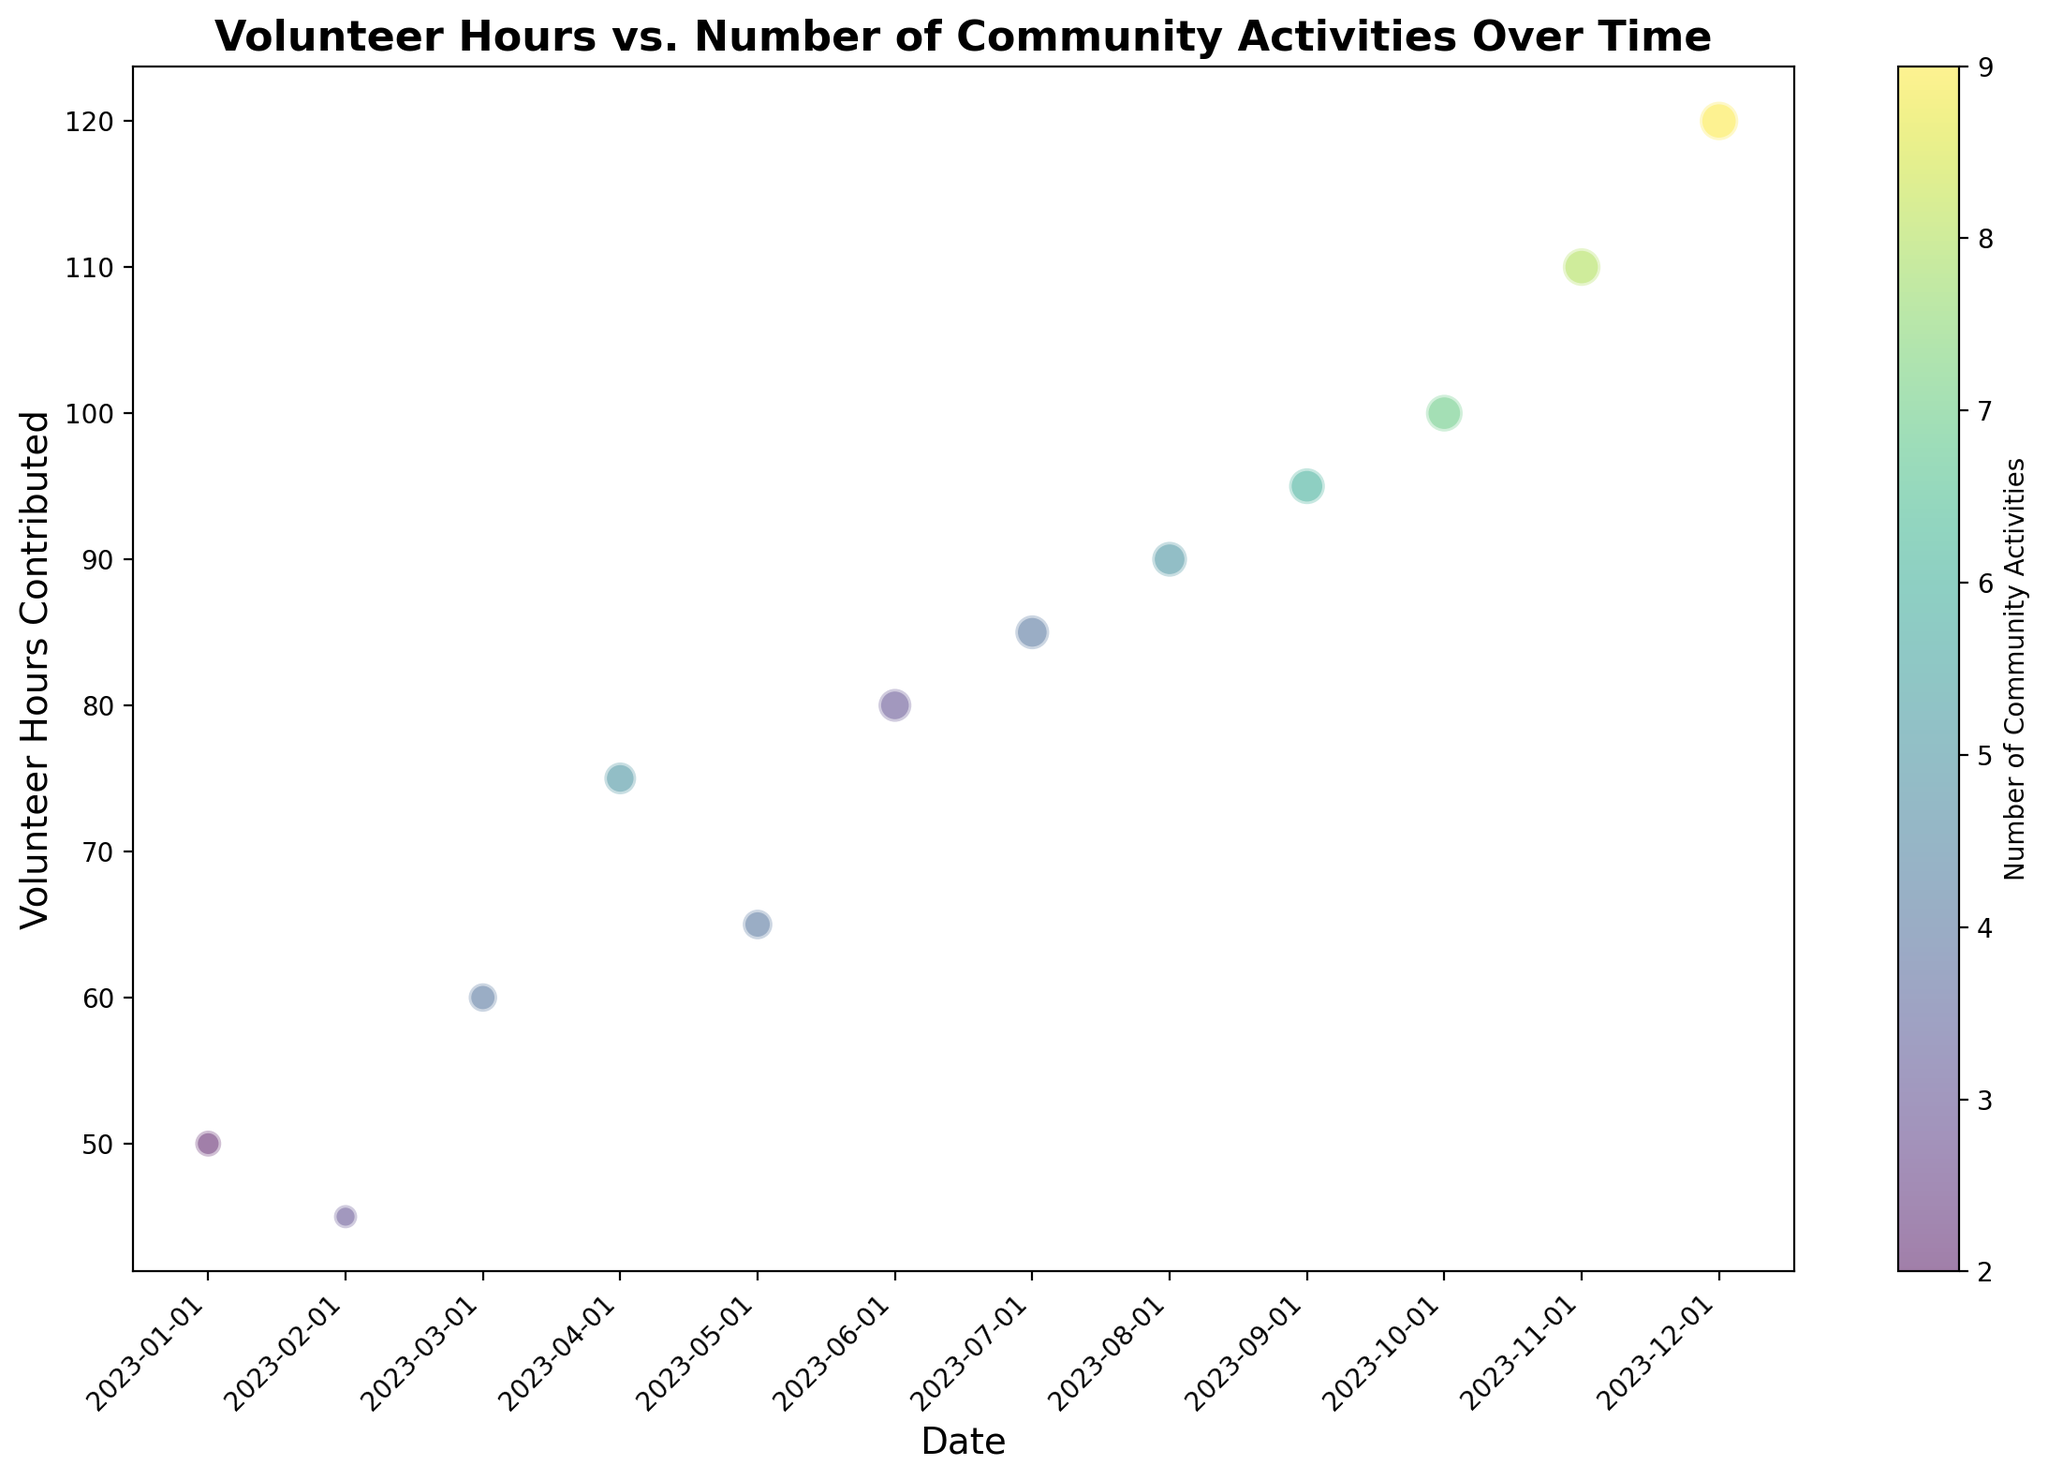What is the month with the highest number of volunteer hours? Observing the y-axis representing volunteer hours, the highest value appears in December with 120 hours.
Answer: December How many volunteer hours were contributed in March, and how many community activities were there that month? By looking at the bubble located at March, the y-axis shows 60 volunteer hours, and the color bar indicates 4 community activities.
Answer: 60 hours and 4 activities What is the difference in the number of activities between July and September? According to the color bar and the specific month markers, July had 4 activities while September had 6. The difference is 6 - 4.
Answer: 2 activities Which month saw the largest increase in volunteer hours compared to the previous month? Comparing month-over-month volunteer hours on the y-axis, the largest increase is observed from August (90 hours) to September (95 hours), an increase of 30 hours.
Answer: September What is the average number of community activities from January to June? Adding the number of community activities from January to June: 2 + 3 + 4 + 5 + 4 + 3 = 21, then dividing by 6 (number of months): 21/6 = 3.5.
Answer: 3.5 activities During which month did the volunteer hours not show a marked difference despite an increase in the number of community activities compared to the previous month? Observing May (65 hours, 4 activities) and June (80 hours, 3 activities), although there are different activities, the number of hours remains relatively stable.
Answer: May Which bubble is the largest in size and what does it represent in terms of date, volunteer hours, and number of activities? The largest bubble is observed in December, indicating 120 volunteer hours and 9 community activities.
Answer: December, 120 hours, 9 activities Comparing April and July, which month had more volunteer hours contributed, and by how much? April had 75 volunteer hours, while July had 85. The difference is 85 - 75.
Answer: July by 10 hours What overall trend can be observed from the plot between volunteer hours and the number of community activities over time? From January to December, there is an overall increasing trend in both volunteer hours and the number of community activities, as indicated by the increasing y-axis values and changing colors toward higher values on the color bar.
Answer: Increasing How does the relationship between the bubble sizes and the number of community activities work in this plot? As the bubble sizes and color intensity increases from left to right, it indicates an increasing number of activities. For instance, December has the biggest bubble and the color indicates 9 activities.
Answer: Larger bubbles indicate more activities 